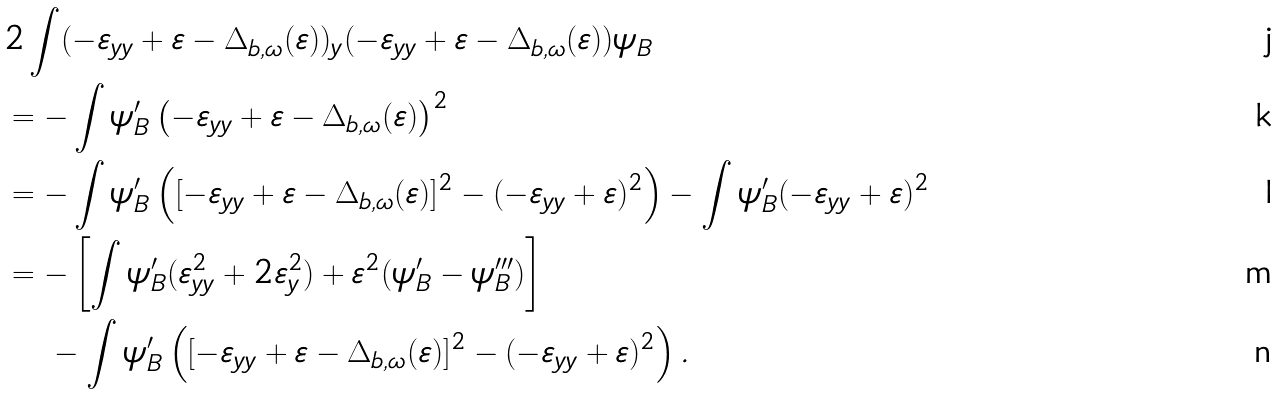Convert formula to latex. <formula><loc_0><loc_0><loc_500><loc_500>& 2 \int ( - \varepsilon _ { y y } + \varepsilon - \Delta _ { b , \omega } ( \varepsilon ) ) _ { y } ( - \varepsilon _ { y y } + \varepsilon - \Delta _ { b , \omega } ( \varepsilon ) ) \psi _ { B } \\ & = - \int \psi _ { B } ^ { \prime } \left ( - \varepsilon _ { y y } + \varepsilon - \Delta _ { b , \omega } ( \varepsilon ) \right ) ^ { 2 } \\ & = - \int \psi _ { B } ^ { \prime } \left ( [ - \varepsilon _ { y y } + \varepsilon - \Delta _ { b , \omega } ( \varepsilon ) ] ^ { 2 } - ( - \varepsilon _ { y y } + \varepsilon ) ^ { 2 } \right ) - \int \psi _ { B } ^ { \prime } ( - \varepsilon _ { y y } + \varepsilon ) ^ { 2 } \\ & = - \left [ \int \psi _ { B } ^ { \prime } ( \varepsilon _ { y y } ^ { 2 } + 2 \varepsilon _ { y } ^ { 2 } ) + \varepsilon ^ { 2 } ( \psi _ { B } ^ { \prime } - \psi _ { B } ^ { \prime \prime \prime } ) \right ] \\ & \quad \, - \int \psi _ { B } ^ { \prime } \left ( [ - \varepsilon _ { y y } + \varepsilon - \Delta _ { b , \omega } ( \varepsilon ) ] ^ { 2 } - ( - \varepsilon _ { y y } + \varepsilon ) ^ { 2 } \right ) .</formula> 